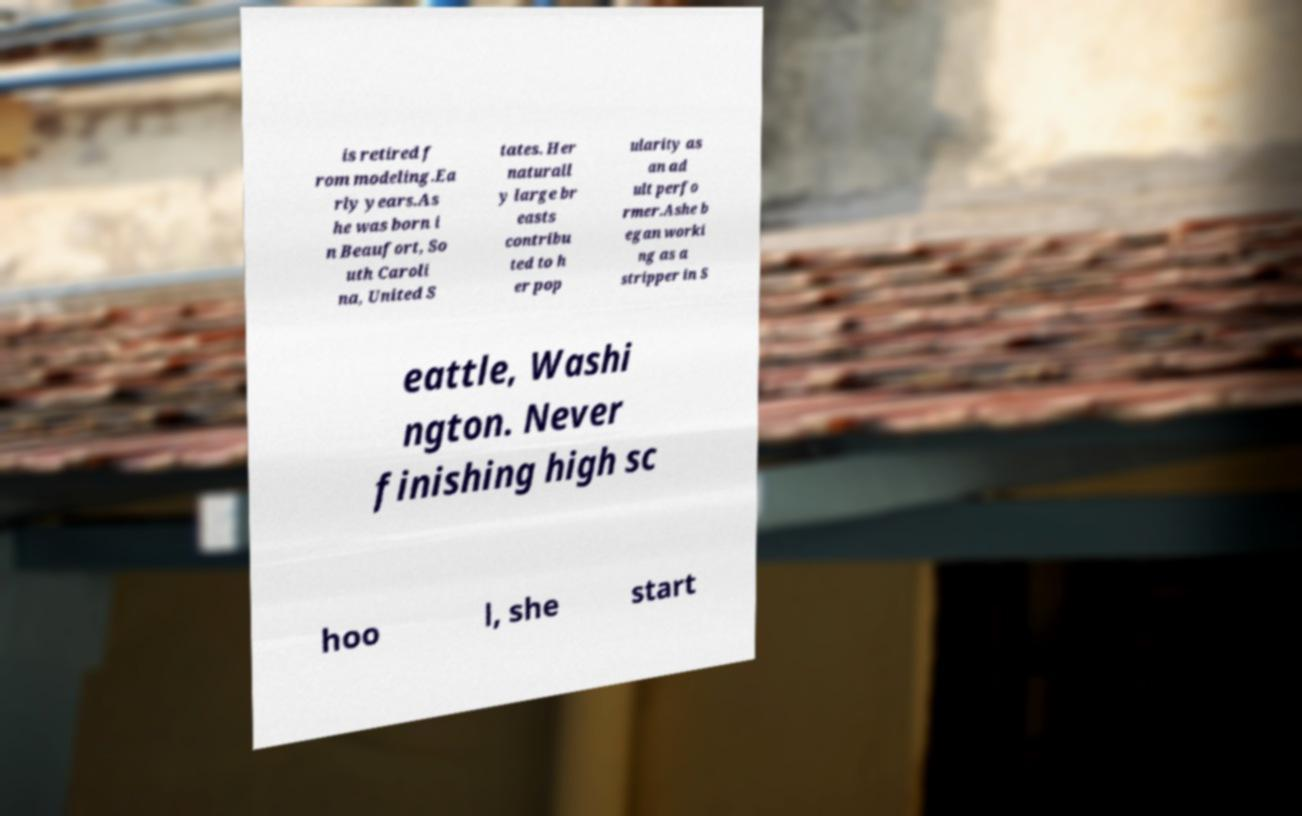Please identify and transcribe the text found in this image. is retired f rom modeling.Ea rly years.As he was born i n Beaufort, So uth Caroli na, United S tates. Her naturall y large br easts contribu ted to h er pop ularity as an ad ult perfo rmer.Ashe b egan worki ng as a stripper in S eattle, Washi ngton. Never finishing high sc hoo l, she start 